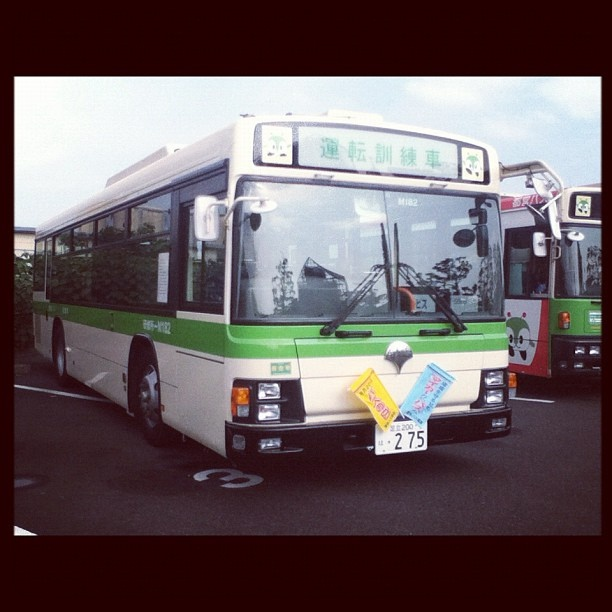Describe the objects in this image and their specific colors. I can see bus in black, lightgray, gray, and darkgray tones and bus in black, gray, darkgray, and maroon tones in this image. 